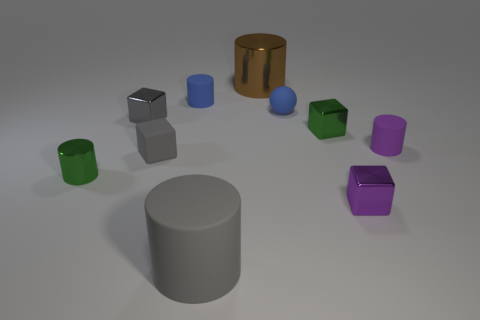Subtract all tiny purple cubes. How many cubes are left? 3 Subtract 1 cubes. How many cubes are left? 3 Subtract all green cubes. How many cubes are left? 3 Subtract all spheres. How many objects are left? 9 Add 3 tiny purple metallic objects. How many tiny purple metallic objects are left? 4 Add 3 tiny cylinders. How many tiny cylinders exist? 6 Subtract 0 brown balls. How many objects are left? 10 Subtract all gray spheres. Subtract all cyan blocks. How many spheres are left? 1 Subtract all cyan cylinders. How many gray blocks are left? 2 Subtract all cyan shiny balls. Subtract all gray rubber blocks. How many objects are left? 9 